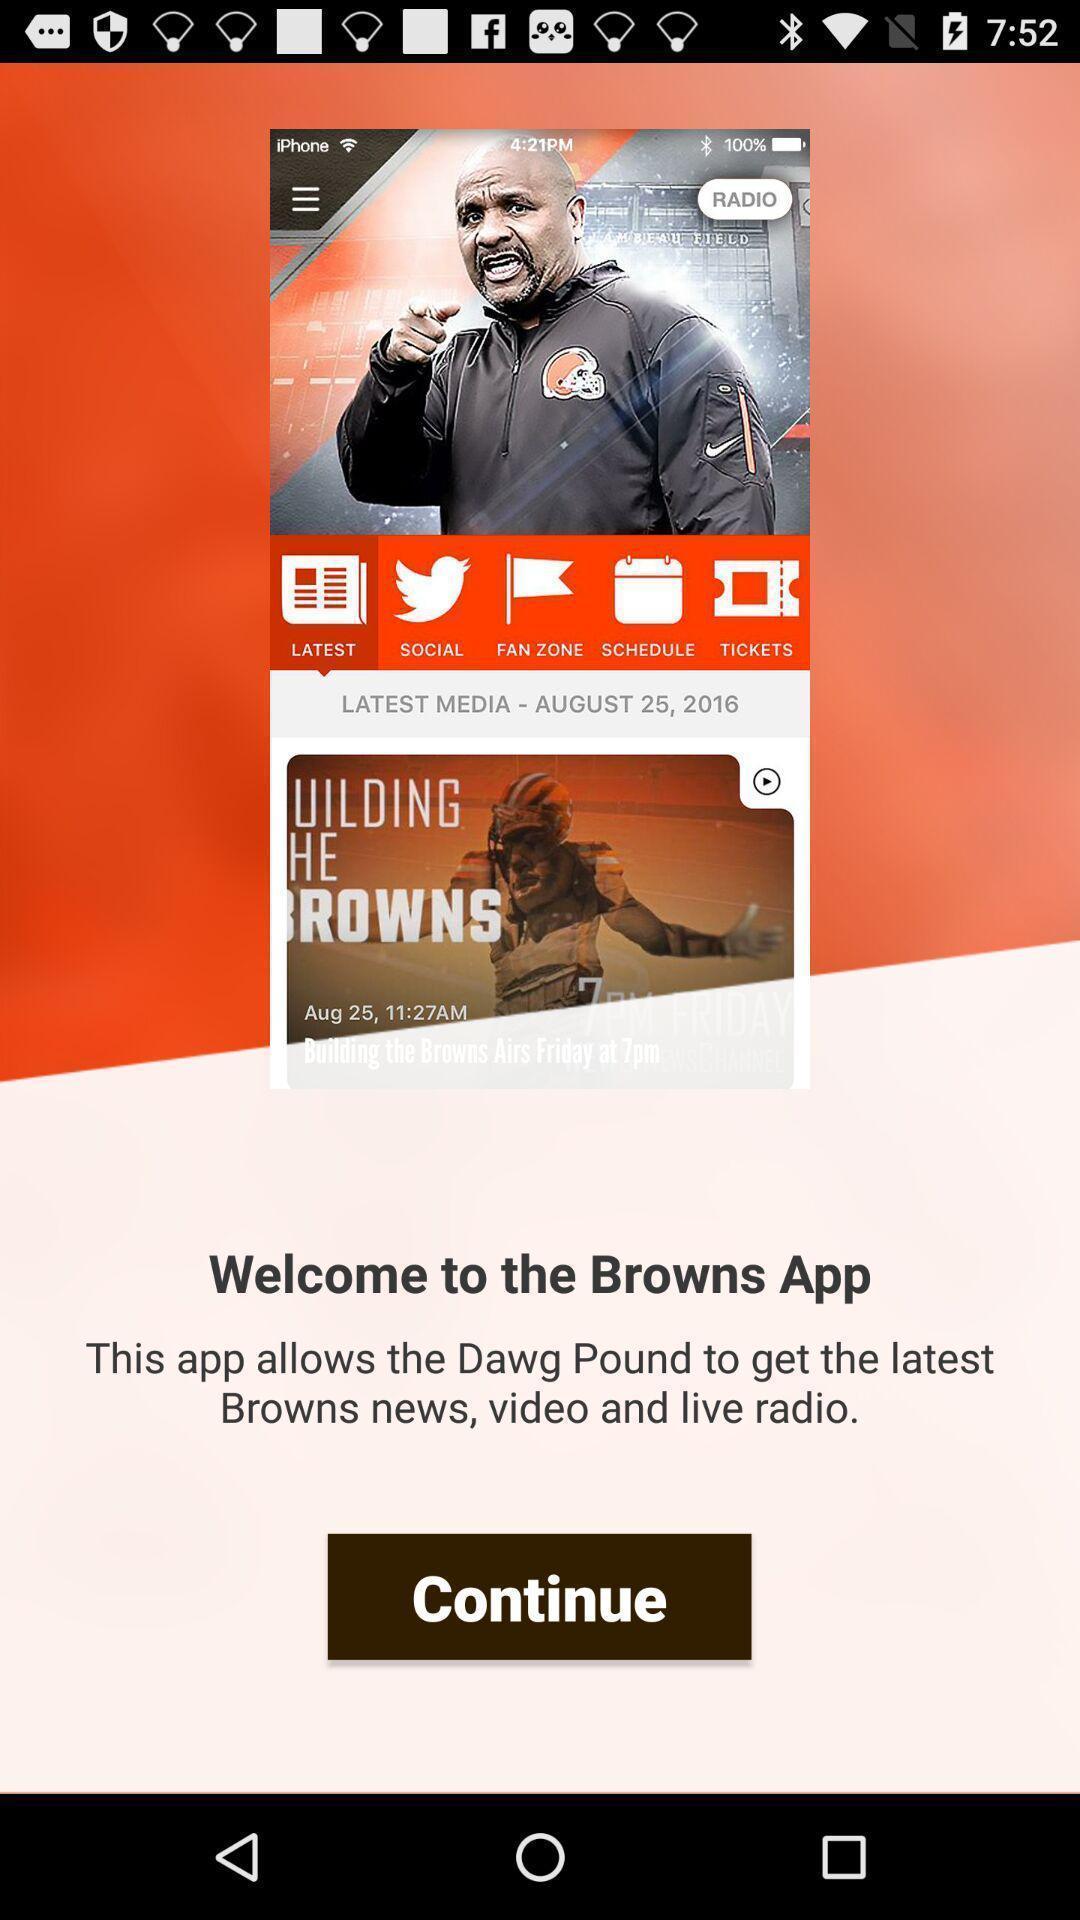Explain the elements present in this screenshot. Welcome page of an entertainment app. 